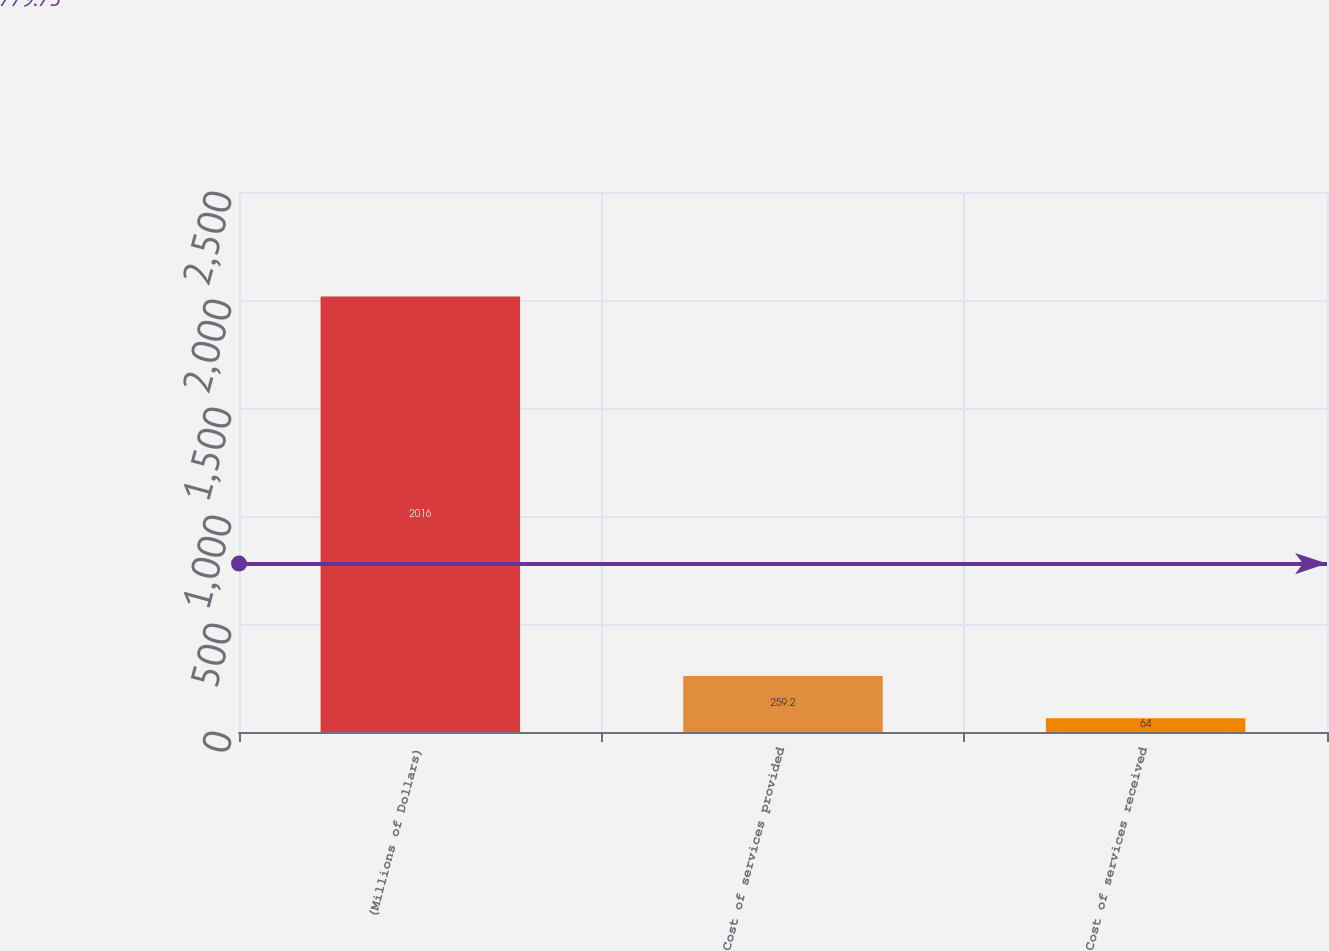Convert chart to OTSL. <chart><loc_0><loc_0><loc_500><loc_500><bar_chart><fcel>(Millions of Dollars)<fcel>Cost of services provided<fcel>Cost of services received<nl><fcel>2016<fcel>259.2<fcel>64<nl></chart> 